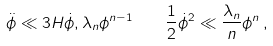<formula> <loc_0><loc_0><loc_500><loc_500>\ddot { \phi } \ll 3 H \dot { \phi } , \lambda _ { n } \phi ^ { n - 1 } \quad \frac { 1 } { 2 } \dot { \phi } ^ { 2 } \ll \frac { \lambda _ { n } } { n } \phi ^ { n } \, ,</formula> 